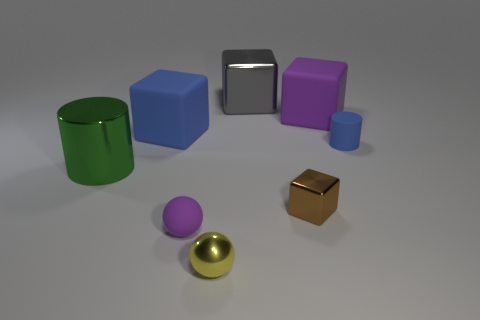Is the color of the shiny cylinder the same as the shiny thing behind the green metal object?
Provide a succinct answer. No. The big metal cylinder that is in front of the small matte object behind the green metallic thing is what color?
Provide a short and direct response. Green. There is a blue rubber object that is left of the large purple rubber block that is right of the yellow thing; is there a yellow object right of it?
Provide a short and direct response. Yes. The large cylinder that is the same material as the small brown thing is what color?
Your answer should be very brief. Green. How many purple balls are made of the same material as the small blue object?
Offer a terse response. 1. Are the small brown object and the block that is to the right of the tiny shiny block made of the same material?
Give a very brief answer. No. What number of objects are either things that are to the right of the green cylinder or big gray spheres?
Provide a succinct answer. 7. There is a purple thing that is right of the big shiny object that is behind the cylinder that is in front of the small blue matte thing; what is its size?
Offer a very short reply. Large. There is a block that is the same color as the tiny matte cylinder; what is its material?
Make the answer very short. Rubber. Is there any other thing that has the same shape as the green object?
Ensure brevity in your answer.  Yes. 